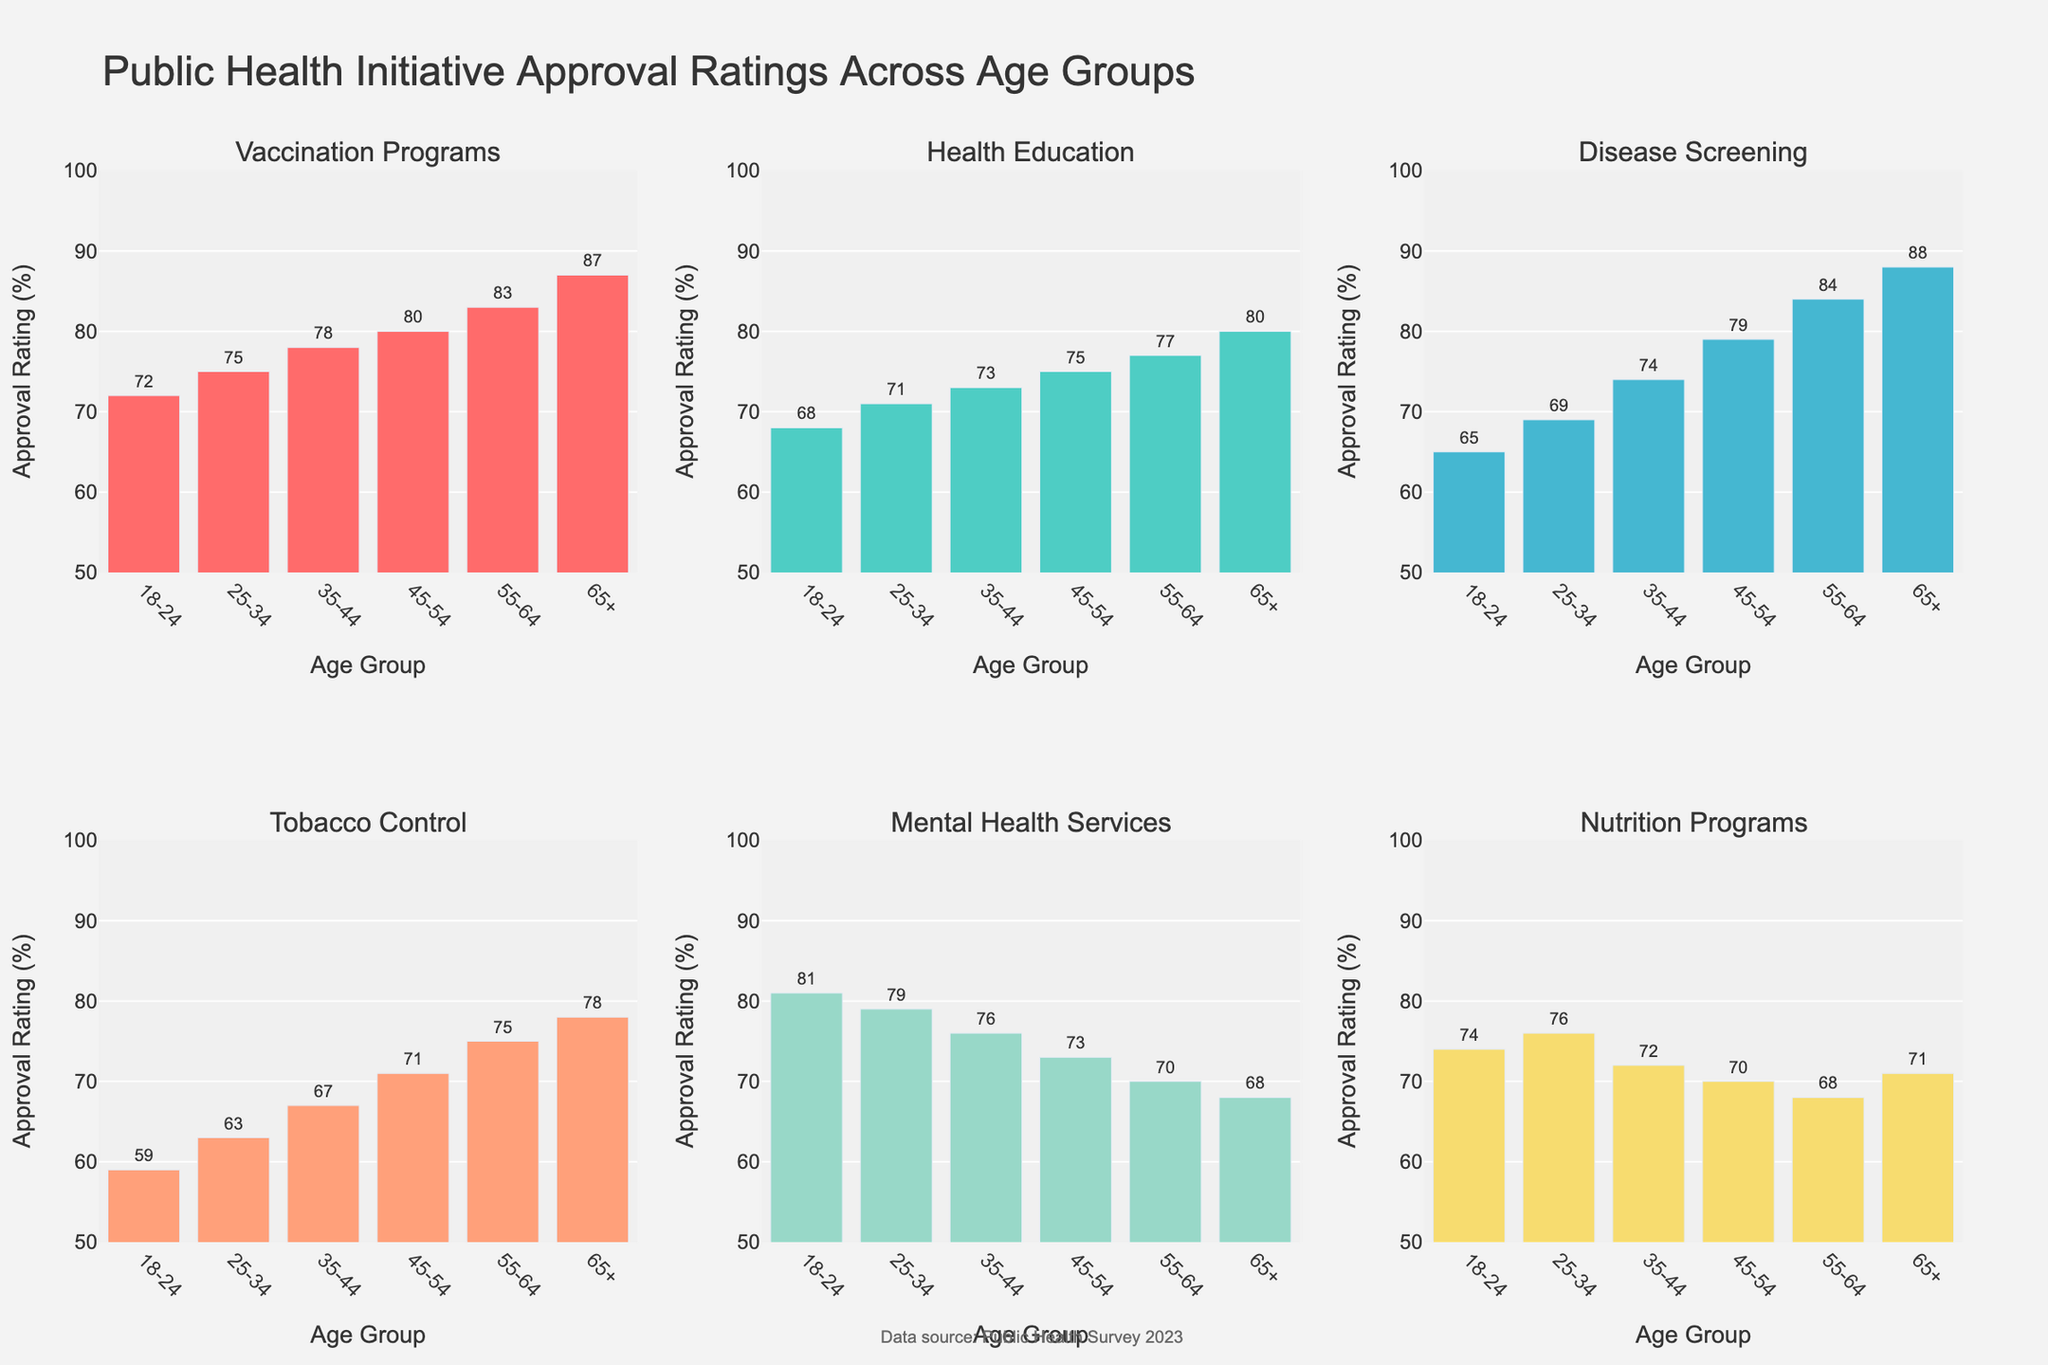Which age group has the highest approval rating for Mental Health Services? The approval ratings for Mental Health Services are shown in different bar heights for each age group. The 18-24 group has a rating of 81, 25-34 has 79, 35-44 has 76, 45-54 has 73, 55-64 has 70, and 65+ has 68. By visual comparison, the 18-24 age group has the highest approval rating at 81.
Answer: 18-24 Which initiative has the lowest approval rating among the 65+ age group? The approval ratings for the 65+ age group are 87 for Vaccination Programs, 80 for Health Education, 88 for Disease Screening, 78 for Tobacco Control, 68 for Mental Health Services, and 71 for Nutrition Programs. By comparing these values, Mental Health Services has the lowest rating of 68.
Answer: Mental Health Services What is the average approval rating for the 55-64 age group across all initiatives? The approval ratings in the 55-64 age group are 83 (Vaccination Programs), 77 (Health Education), 84 (Disease Screening), 75 (Tobacco Control), 70 (Mental Health Services), 68 (Nutrition Programs). Summing these: 83 + 77 + 84 + 75 + 70 + 68 = 457. The average is 457 / 6 = 76.17.
Answer: 76.17 Is the approval rating for Health Education higher in the 25-34 age group than in the 45-54 age group? The approval rating for Health Education in the 25-34 age group is 71, and in the 45-54 age group, it is 75. By comparing the two numbers, 75 is greater than 71, so no, it is not higher.
Answer: No Which two initiatives have the closest approval ratings in the 35-44 age group? The approval ratings in the 35-44 age group are as follows: Vaccination Programs (78), Health Education (73), Disease Screening (74), Tobacco Control (67), Mental Health Services (76), Nutrition Programs (72). The closest pair is Health Education (73) and Nutrition Programs (72), with a difference of 1.
Answer: Health Education and Nutrition Programs What is the difference in approval rating for Tobacco Control between the 18-24 and 65+ age groups? The approval rating for Tobacco Control in the 18-24 age group is 59 and in the 65+ age group is 78. The difference is 78 - 59 = 19.
Answer: 19 Which initiative has the most approval variation across age groups? By observing the range of approval ratings for all initiatives: Vaccination Programs (72-87), Health Education (68-80), Disease Screening (65-88), Tobacco Control (59-78), Mental Health Services (68-81), Nutrition Programs (68-76). Disease Screening varies from 65 to 88, a range of 23, which is the largest variation.
Answer: Disease Screening Which age group has the most consistent (least varied) approval ratings across all initiatives? To determine consistency, look at the variability within each age group's ratings. The 18-24 group: 72-81, 25-34 group: 63-79, 35-44 group: 67-78, 45-54 group: 70-80, 55-64 group: 68-84, 65+ group: 68-88. The smallest range is for the 45-54 age group, where approval ratings vary by only 10 points (70-80).
Answer: 45-54 What is the sum of approval ratings for Health Education across all age groups? The approval ratings for Health Education are 68 (18-24), 71 (25-34), 73 (35-44), 75 (45-54), 77 (55-64), 80 (65+). Summing these values: 68 + 71 + 73 + 75 + 77 + 80 = 444.
Answer: 444 